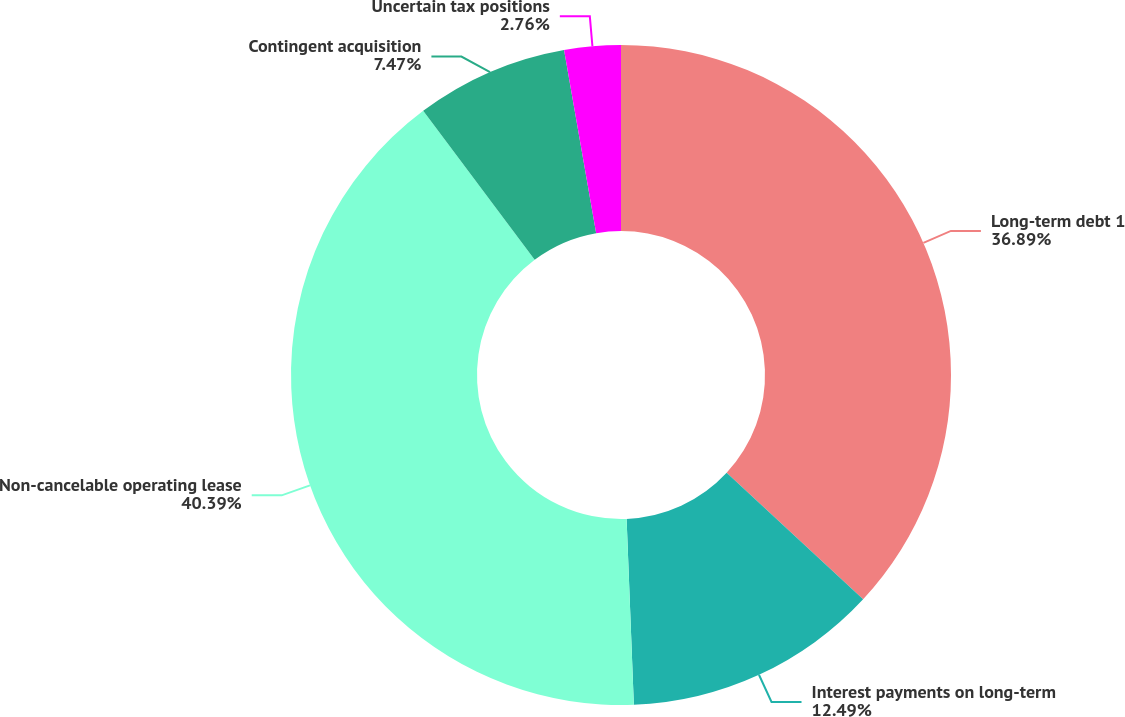Convert chart to OTSL. <chart><loc_0><loc_0><loc_500><loc_500><pie_chart><fcel>Long-term debt 1<fcel>Interest payments on long-term<fcel>Non-cancelable operating lease<fcel>Contingent acquisition<fcel>Uncertain tax positions<nl><fcel>36.89%<fcel>12.49%<fcel>40.39%<fcel>7.47%<fcel>2.76%<nl></chart> 